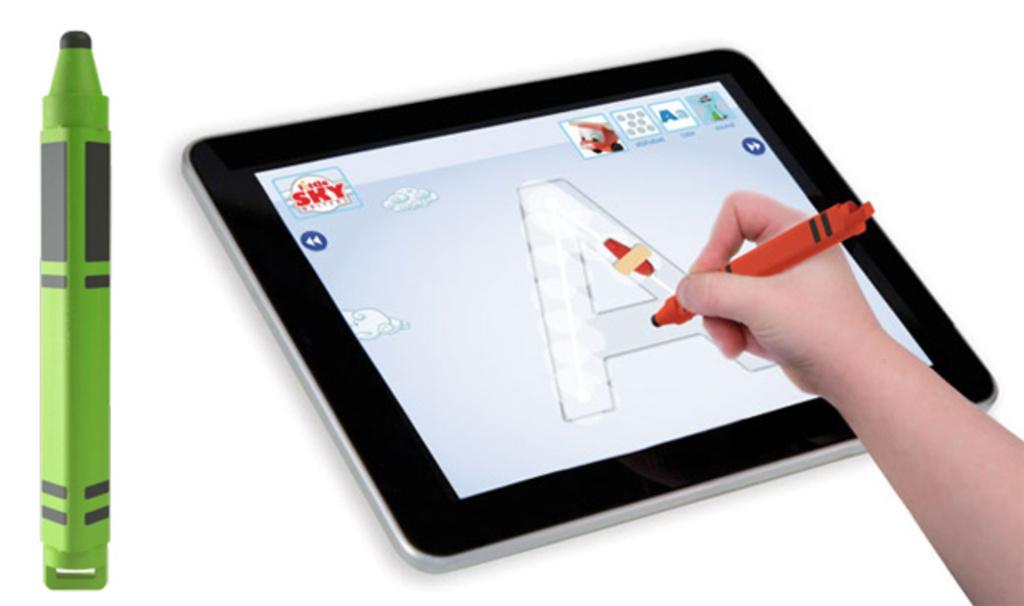In one or two sentences, can you explain what this image depicts? On the left side of the image we can see the marker. In the middle of the image we can see a tab in which alphabet A is displayed. On the right side of the image we can see a hand and a red color marker. 